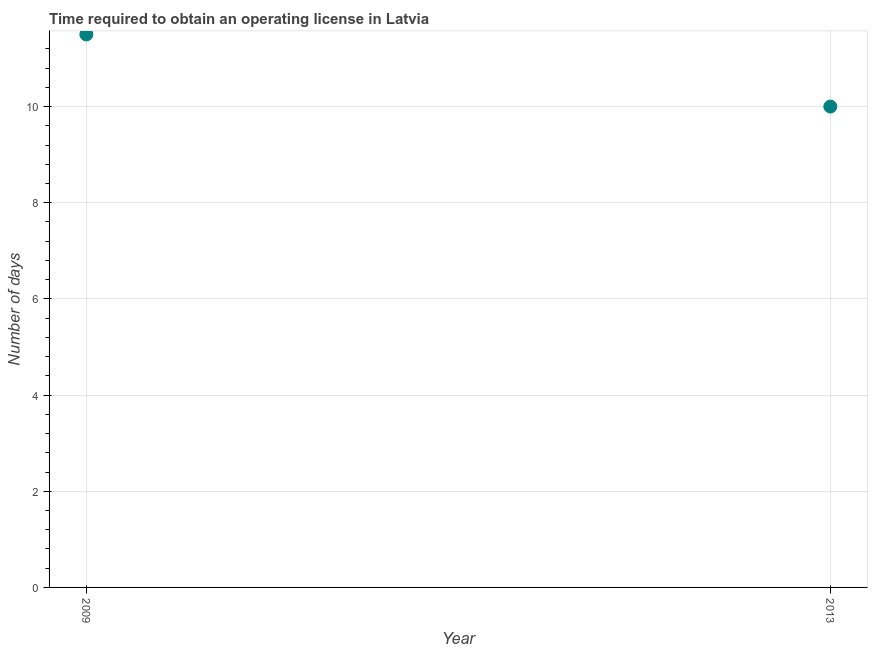Across all years, what is the maximum number of days to obtain operating license?
Provide a short and direct response. 11.5. Across all years, what is the minimum number of days to obtain operating license?
Offer a very short reply. 10. What is the difference between the number of days to obtain operating license in 2009 and 2013?
Offer a very short reply. 1.5. What is the average number of days to obtain operating license per year?
Provide a short and direct response. 10.75. What is the median number of days to obtain operating license?
Offer a terse response. 10.75. In how many years, is the number of days to obtain operating license greater than 1.2000000000000002 days?
Offer a very short reply. 2. What is the ratio of the number of days to obtain operating license in 2009 to that in 2013?
Your response must be concise. 1.15. Does the number of days to obtain operating license monotonically increase over the years?
Offer a terse response. No. How many dotlines are there?
Provide a short and direct response. 1. How many years are there in the graph?
Your answer should be compact. 2. What is the difference between two consecutive major ticks on the Y-axis?
Provide a succinct answer. 2. Are the values on the major ticks of Y-axis written in scientific E-notation?
Your response must be concise. No. What is the title of the graph?
Your answer should be compact. Time required to obtain an operating license in Latvia. What is the label or title of the X-axis?
Provide a succinct answer. Year. What is the label or title of the Y-axis?
Provide a succinct answer. Number of days. What is the Number of days in 2013?
Offer a terse response. 10. What is the ratio of the Number of days in 2009 to that in 2013?
Your answer should be compact. 1.15. 